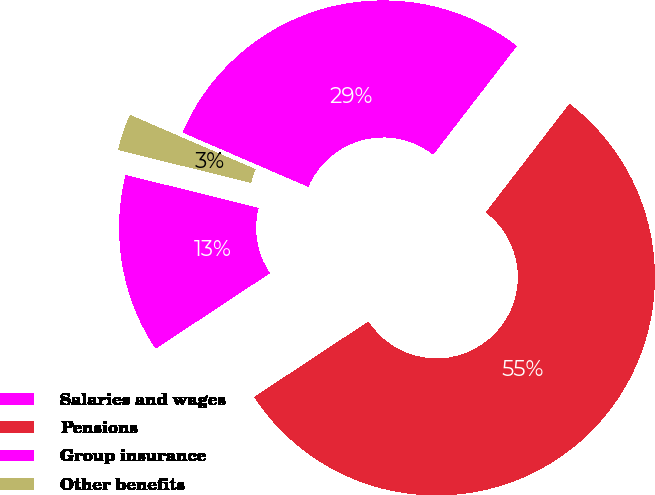Convert chart to OTSL. <chart><loc_0><loc_0><loc_500><loc_500><pie_chart><fcel>Salaries and wages<fcel>Pensions<fcel>Group insurance<fcel>Other benefits<nl><fcel>13.16%<fcel>55.26%<fcel>28.95%<fcel>2.63%<nl></chart> 